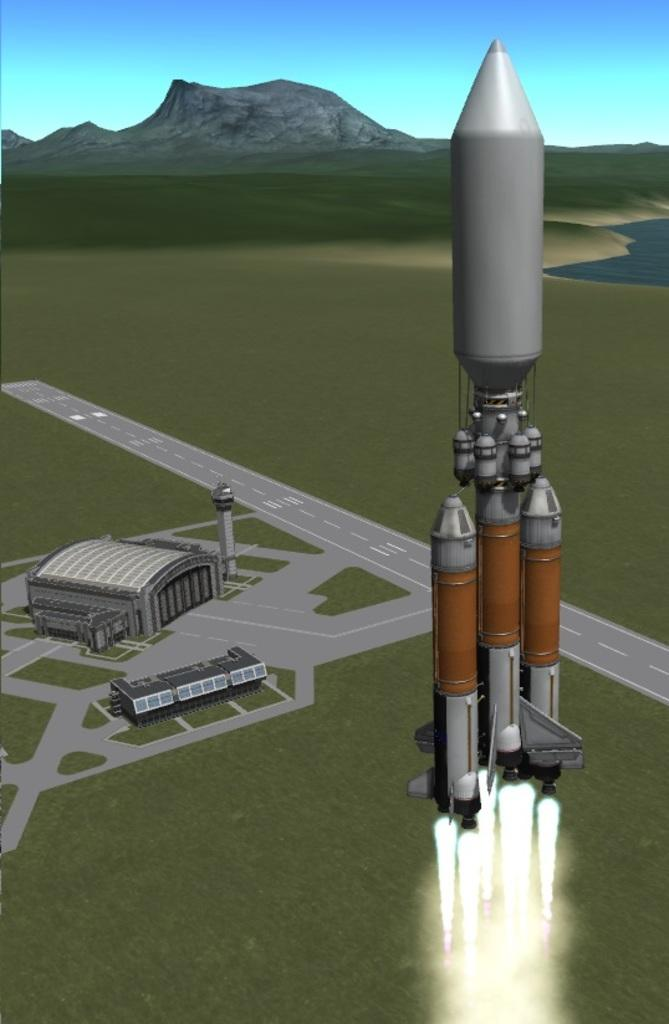What is the main subject of the image? The main subject of the image is a rocket. What other structures or objects can be seen in the image? There is a building and a hill visible in the image. What natural element is present in the image? Groundwater is visible in the image. What is visible at the top of the image? The sky is visible at the top of the image. How many parents are present in the image? There are no parents present in the image; it features a rocket, a building, groundwater, a hill, and the sky. What type of queen can be seen in the image? There is no queen present in the image; it features a rocket, a building, groundwater, a hill, and the sky. 